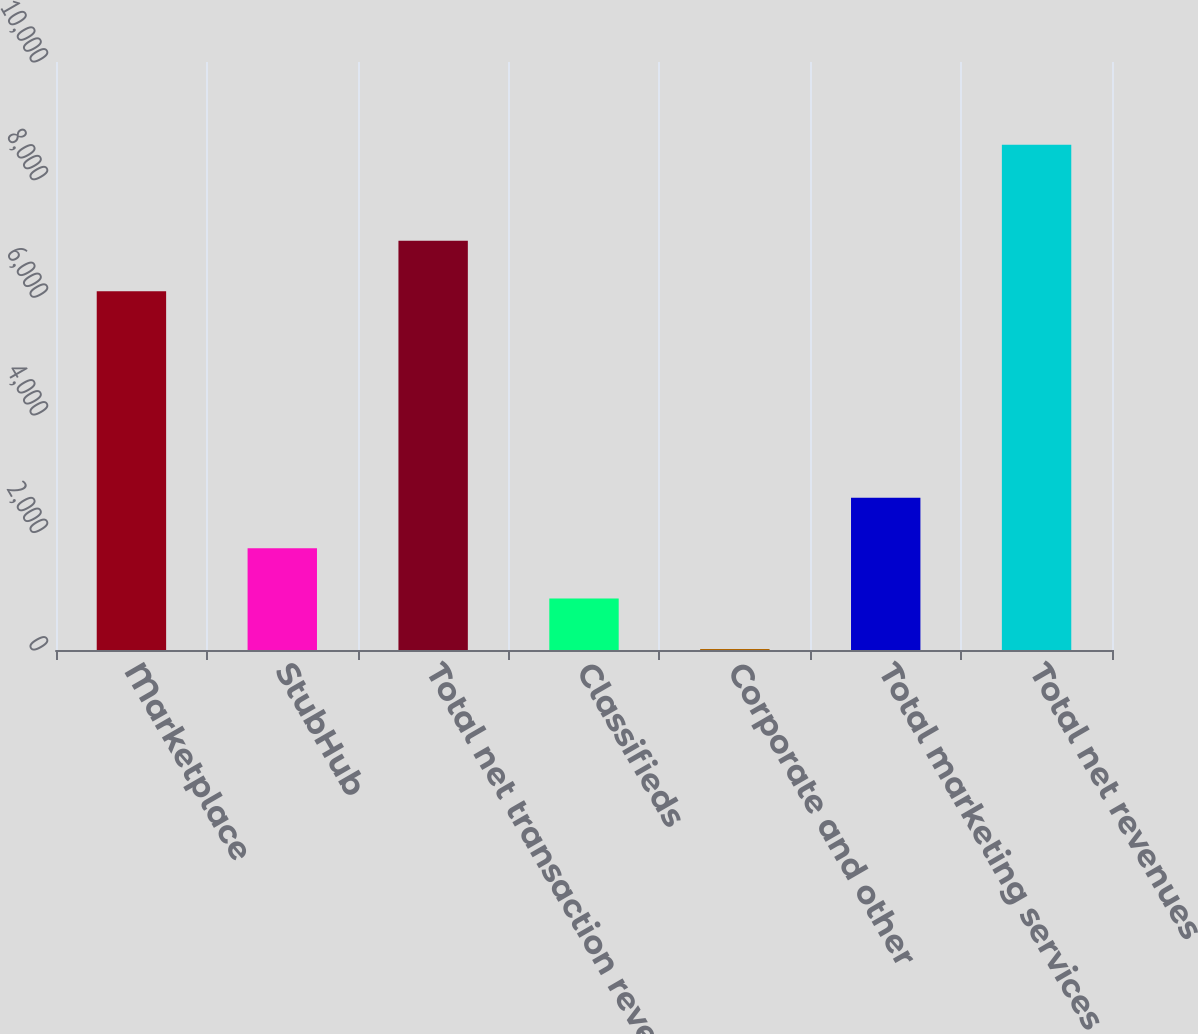<chart> <loc_0><loc_0><loc_500><loc_500><bar_chart><fcel>Marketplace<fcel>StubHub<fcel>Total net transaction revenues<fcel>Classifieds<fcel>Corporate and other<fcel>Total marketing services and<fcel>Total net revenues<nl><fcel>6103<fcel>1732<fcel>6960.5<fcel>874.5<fcel>17<fcel>2589.5<fcel>8592<nl></chart> 